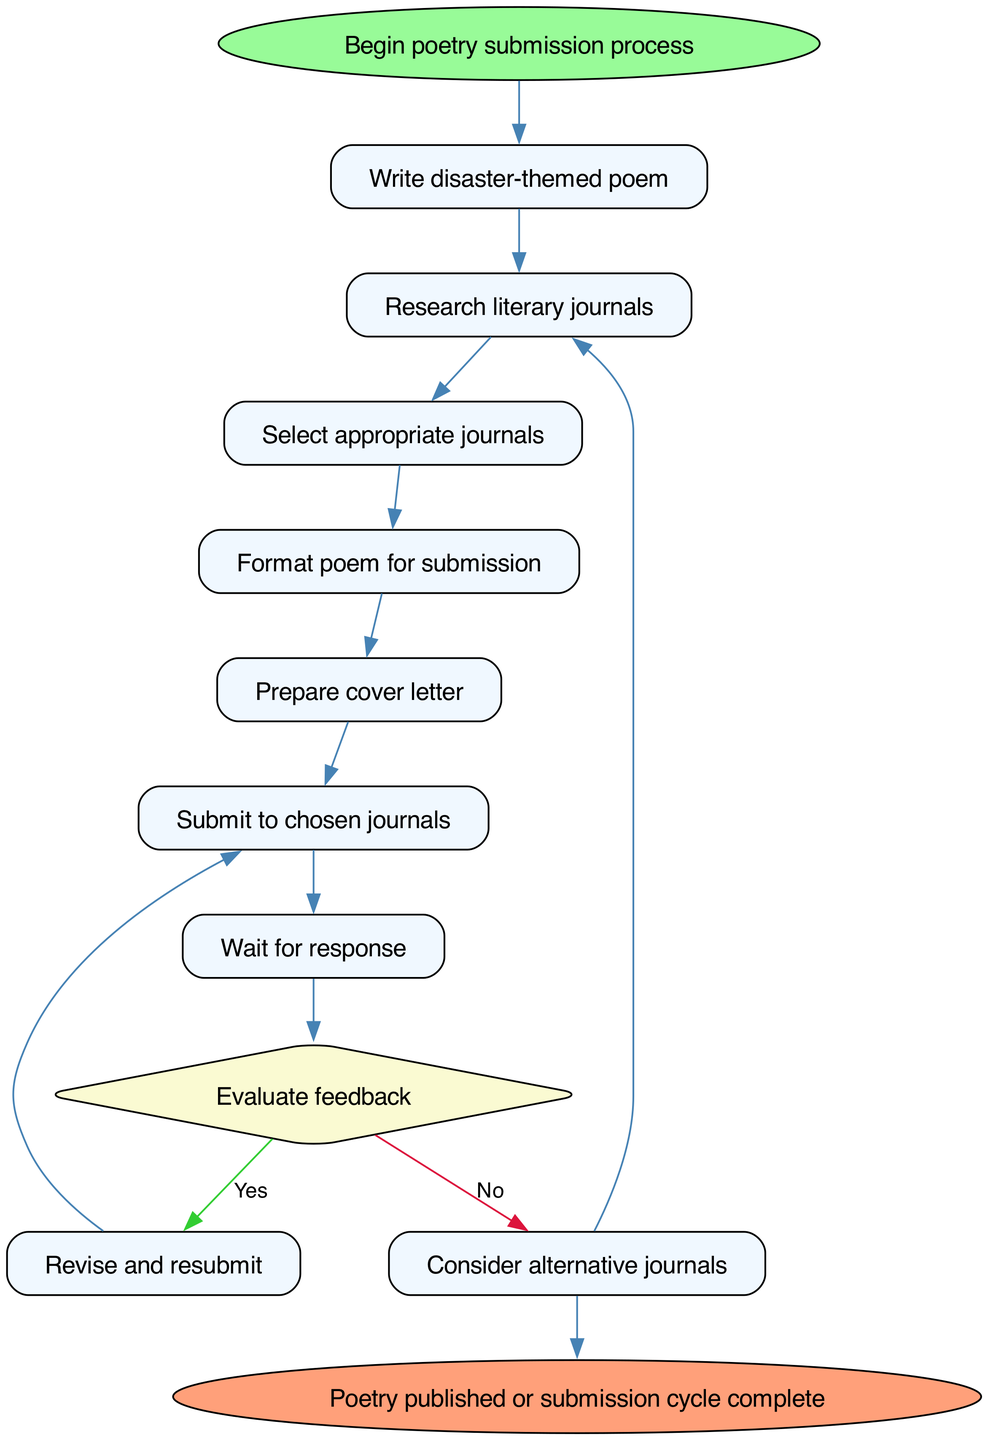What is the first step in the process? The diagram starts with the node labeled "Begin poetry submission process", which indicates the initiation of the process. The subsequent step is "Write disaster-themed poem".
Answer: Write disaster-themed poem How many steps are there in the process? Counting the nodes, there are eight distinct steps listed in the diagram before reaching the end.
Answer: Eight What is the final outcome of the process? At the end of the diagram, the node states "Poetry published or submission cycle complete", indicating what results from following the process.
Answer: Poetry published or submission cycle complete What should you do after submitting to chosen journals? The next step after submitting your work is to "Wait for response", which follows directly from the submission action.
Answer: Wait for response If the feedback is positive, what is the next step? The diagram indicates that if the evaluation of feedback is "Yes", the next step is "Revise and resubmit", which follows as a direct action based on positive feedback.
Answer: Revise and resubmit What step follows "Prepare cover letter"? After the "Prepare cover letter" step, the diagram flows to "Submit to chosen journals", marking the transition from preparation to submission.
Answer: Submit to chosen journals What do you do if the feedback is negative? According to the diagram, if the feedback is not favorable (No), you "Consider alternative journals" as the alternative action to take.
Answer: Consider alternative journals Which step requires research? The steps that involve research include "Research literary journals", which appears twice in the process, indicating the importance of this action at different points.
Answer: Research literary journals 